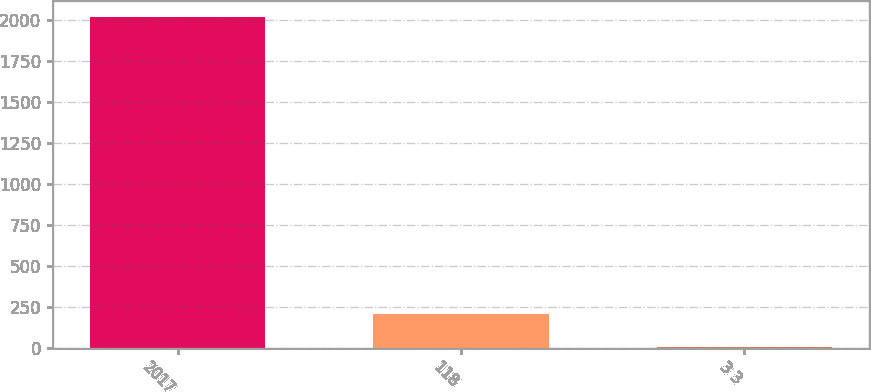Convert chart to OTSL. <chart><loc_0><loc_0><loc_500><loc_500><bar_chart><fcel>2017<fcel>118<fcel>3 3<nl><fcel>2015<fcel>206.9<fcel>6<nl></chart> 